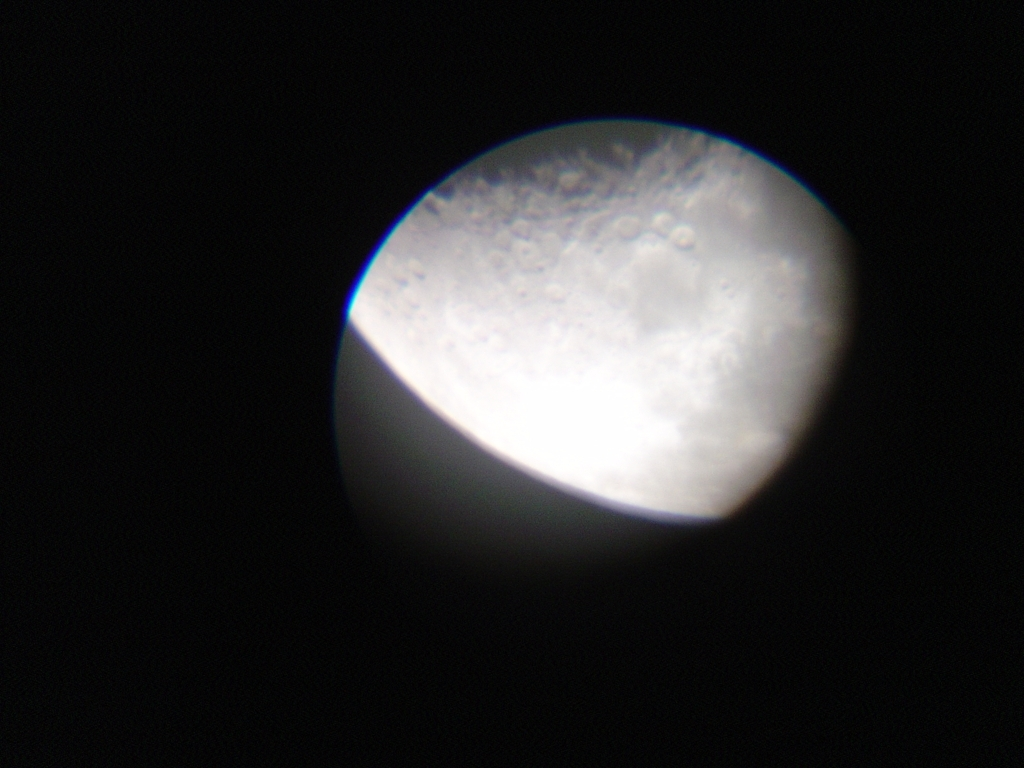What phase of the Moon is shown in this image? Based on the amount of the Moon that is illuminated and the angle of the sunlight, this image most likely shows the waxing gibbous phase. In this phase, more than half of the Moon's face appears lit up, but it's not yet fully bright like during a full moon. How can I take better pictures of the Moon? For better lunar photography, use a high-resolution camera with a good zoom or a telescope with a mount for your camera or smartphone. Take photos during clear nights and use a tripod to avoid blurriness. Experiment with the camera settings, such as ISO, aperture, and shutter speed, to get the clearest image possible. 